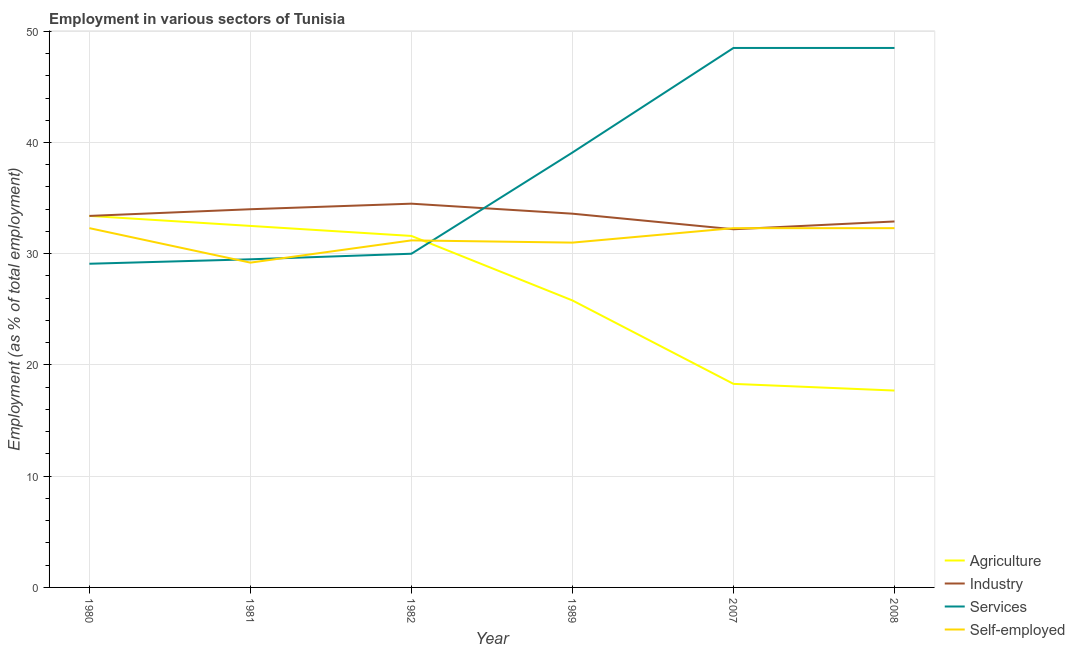How many different coloured lines are there?
Your response must be concise. 4. What is the percentage of workers in services in 2007?
Keep it short and to the point. 48.5. Across all years, what is the maximum percentage of workers in industry?
Give a very brief answer. 34.5. Across all years, what is the minimum percentage of workers in industry?
Provide a short and direct response. 32.2. In which year was the percentage of workers in industry maximum?
Keep it short and to the point. 1982. In which year was the percentage of workers in services minimum?
Ensure brevity in your answer.  1980. What is the total percentage of workers in services in the graph?
Offer a very short reply. 224.7. What is the difference between the percentage of workers in agriculture in 2007 and that in 2008?
Offer a terse response. 0.6. What is the difference between the percentage of workers in services in 1982 and the percentage of workers in industry in 2008?
Keep it short and to the point. -2.9. What is the average percentage of workers in services per year?
Ensure brevity in your answer.  37.45. In the year 1989, what is the difference between the percentage of workers in agriculture and percentage of workers in services?
Your answer should be very brief. -13.3. In how many years, is the percentage of workers in services greater than 2 %?
Offer a very short reply. 6. What is the ratio of the percentage of workers in services in 1989 to that in 2007?
Give a very brief answer. 0.81. What is the difference between the highest and the second highest percentage of workers in industry?
Keep it short and to the point. 0.5. What is the difference between the highest and the lowest percentage of self employed workers?
Make the answer very short. 3.1. In how many years, is the percentage of workers in services greater than the average percentage of workers in services taken over all years?
Your answer should be very brief. 3. Does the percentage of workers in agriculture monotonically increase over the years?
Offer a terse response. No. How many lines are there?
Offer a terse response. 4. Are the values on the major ticks of Y-axis written in scientific E-notation?
Offer a terse response. No. Does the graph contain any zero values?
Provide a succinct answer. No. Does the graph contain grids?
Provide a succinct answer. Yes. Where does the legend appear in the graph?
Keep it short and to the point. Bottom right. How many legend labels are there?
Offer a terse response. 4. How are the legend labels stacked?
Provide a short and direct response. Vertical. What is the title of the graph?
Give a very brief answer. Employment in various sectors of Tunisia. What is the label or title of the X-axis?
Your response must be concise. Year. What is the label or title of the Y-axis?
Make the answer very short. Employment (as % of total employment). What is the Employment (as % of total employment) of Agriculture in 1980?
Your answer should be compact. 33.4. What is the Employment (as % of total employment) of Industry in 1980?
Offer a very short reply. 33.4. What is the Employment (as % of total employment) of Services in 1980?
Your answer should be very brief. 29.1. What is the Employment (as % of total employment) in Self-employed in 1980?
Give a very brief answer. 32.3. What is the Employment (as % of total employment) in Agriculture in 1981?
Ensure brevity in your answer.  32.5. What is the Employment (as % of total employment) in Industry in 1981?
Offer a very short reply. 34. What is the Employment (as % of total employment) in Services in 1981?
Your response must be concise. 29.5. What is the Employment (as % of total employment) in Self-employed in 1981?
Keep it short and to the point. 29.2. What is the Employment (as % of total employment) in Agriculture in 1982?
Your answer should be compact. 31.6. What is the Employment (as % of total employment) in Industry in 1982?
Your answer should be very brief. 34.5. What is the Employment (as % of total employment) in Self-employed in 1982?
Keep it short and to the point. 31.2. What is the Employment (as % of total employment) of Agriculture in 1989?
Offer a very short reply. 25.8. What is the Employment (as % of total employment) in Industry in 1989?
Make the answer very short. 33.6. What is the Employment (as % of total employment) of Services in 1989?
Your answer should be compact. 39.1. What is the Employment (as % of total employment) in Self-employed in 1989?
Ensure brevity in your answer.  31. What is the Employment (as % of total employment) in Agriculture in 2007?
Offer a very short reply. 18.3. What is the Employment (as % of total employment) of Industry in 2007?
Make the answer very short. 32.2. What is the Employment (as % of total employment) of Services in 2007?
Provide a succinct answer. 48.5. What is the Employment (as % of total employment) of Self-employed in 2007?
Make the answer very short. 32.3. What is the Employment (as % of total employment) of Agriculture in 2008?
Provide a short and direct response. 17.7. What is the Employment (as % of total employment) of Industry in 2008?
Your response must be concise. 32.9. What is the Employment (as % of total employment) in Services in 2008?
Make the answer very short. 48.5. What is the Employment (as % of total employment) of Self-employed in 2008?
Provide a short and direct response. 32.3. Across all years, what is the maximum Employment (as % of total employment) of Agriculture?
Give a very brief answer. 33.4. Across all years, what is the maximum Employment (as % of total employment) of Industry?
Provide a succinct answer. 34.5. Across all years, what is the maximum Employment (as % of total employment) in Services?
Keep it short and to the point. 48.5. Across all years, what is the maximum Employment (as % of total employment) of Self-employed?
Keep it short and to the point. 32.3. Across all years, what is the minimum Employment (as % of total employment) of Agriculture?
Offer a very short reply. 17.7. Across all years, what is the minimum Employment (as % of total employment) in Industry?
Provide a succinct answer. 32.2. Across all years, what is the minimum Employment (as % of total employment) of Services?
Offer a very short reply. 29.1. Across all years, what is the minimum Employment (as % of total employment) in Self-employed?
Make the answer very short. 29.2. What is the total Employment (as % of total employment) in Agriculture in the graph?
Provide a short and direct response. 159.3. What is the total Employment (as % of total employment) of Industry in the graph?
Your answer should be very brief. 200.6. What is the total Employment (as % of total employment) in Services in the graph?
Your answer should be compact. 224.7. What is the total Employment (as % of total employment) in Self-employed in the graph?
Your answer should be compact. 188.3. What is the difference between the Employment (as % of total employment) of Agriculture in 1980 and that in 1981?
Offer a very short reply. 0.9. What is the difference between the Employment (as % of total employment) of Industry in 1980 and that in 1981?
Give a very brief answer. -0.6. What is the difference between the Employment (as % of total employment) in Industry in 1980 and that in 1982?
Make the answer very short. -1.1. What is the difference between the Employment (as % of total employment) in Self-employed in 1980 and that in 1982?
Give a very brief answer. 1.1. What is the difference between the Employment (as % of total employment) of Agriculture in 1980 and that in 1989?
Your response must be concise. 7.6. What is the difference between the Employment (as % of total employment) of Services in 1980 and that in 1989?
Provide a succinct answer. -10. What is the difference between the Employment (as % of total employment) in Self-employed in 1980 and that in 1989?
Offer a very short reply. 1.3. What is the difference between the Employment (as % of total employment) in Services in 1980 and that in 2007?
Offer a very short reply. -19.4. What is the difference between the Employment (as % of total employment) in Industry in 1980 and that in 2008?
Give a very brief answer. 0.5. What is the difference between the Employment (as % of total employment) in Services in 1980 and that in 2008?
Offer a terse response. -19.4. What is the difference between the Employment (as % of total employment) in Self-employed in 1980 and that in 2008?
Make the answer very short. 0. What is the difference between the Employment (as % of total employment) in Agriculture in 1981 and that in 1989?
Provide a succinct answer. 6.7. What is the difference between the Employment (as % of total employment) of Self-employed in 1981 and that in 1989?
Your answer should be very brief. -1.8. What is the difference between the Employment (as % of total employment) in Agriculture in 1981 and that in 2007?
Your response must be concise. 14.2. What is the difference between the Employment (as % of total employment) of Services in 1981 and that in 2007?
Your answer should be very brief. -19. What is the difference between the Employment (as % of total employment) of Self-employed in 1981 and that in 2007?
Make the answer very short. -3.1. What is the difference between the Employment (as % of total employment) of Services in 1981 and that in 2008?
Keep it short and to the point. -19. What is the difference between the Employment (as % of total employment) in Services in 1982 and that in 1989?
Give a very brief answer. -9.1. What is the difference between the Employment (as % of total employment) in Industry in 1982 and that in 2007?
Give a very brief answer. 2.3. What is the difference between the Employment (as % of total employment) of Services in 1982 and that in 2007?
Give a very brief answer. -18.5. What is the difference between the Employment (as % of total employment) in Self-employed in 1982 and that in 2007?
Ensure brevity in your answer.  -1.1. What is the difference between the Employment (as % of total employment) of Agriculture in 1982 and that in 2008?
Offer a terse response. 13.9. What is the difference between the Employment (as % of total employment) in Services in 1982 and that in 2008?
Offer a very short reply. -18.5. What is the difference between the Employment (as % of total employment) of Self-employed in 1982 and that in 2008?
Offer a terse response. -1.1. What is the difference between the Employment (as % of total employment) of Agriculture in 1989 and that in 2007?
Provide a succinct answer. 7.5. What is the difference between the Employment (as % of total employment) in Agriculture in 1989 and that in 2008?
Ensure brevity in your answer.  8.1. What is the difference between the Employment (as % of total employment) of Services in 1989 and that in 2008?
Ensure brevity in your answer.  -9.4. What is the difference between the Employment (as % of total employment) in Self-employed in 1989 and that in 2008?
Keep it short and to the point. -1.3. What is the difference between the Employment (as % of total employment) of Industry in 2007 and that in 2008?
Keep it short and to the point. -0.7. What is the difference between the Employment (as % of total employment) in Services in 2007 and that in 2008?
Give a very brief answer. 0. What is the difference between the Employment (as % of total employment) of Agriculture in 1980 and the Employment (as % of total employment) of Self-employed in 1981?
Your response must be concise. 4.2. What is the difference between the Employment (as % of total employment) of Agriculture in 1980 and the Employment (as % of total employment) of Self-employed in 1982?
Keep it short and to the point. 2.2. What is the difference between the Employment (as % of total employment) of Industry in 1980 and the Employment (as % of total employment) of Self-employed in 1982?
Your answer should be very brief. 2.2. What is the difference between the Employment (as % of total employment) of Services in 1980 and the Employment (as % of total employment) of Self-employed in 1982?
Ensure brevity in your answer.  -2.1. What is the difference between the Employment (as % of total employment) in Agriculture in 1980 and the Employment (as % of total employment) in Industry in 1989?
Offer a very short reply. -0.2. What is the difference between the Employment (as % of total employment) in Agriculture in 1980 and the Employment (as % of total employment) in Services in 1989?
Make the answer very short. -5.7. What is the difference between the Employment (as % of total employment) of Industry in 1980 and the Employment (as % of total employment) of Self-employed in 1989?
Give a very brief answer. 2.4. What is the difference between the Employment (as % of total employment) of Agriculture in 1980 and the Employment (as % of total employment) of Services in 2007?
Ensure brevity in your answer.  -15.1. What is the difference between the Employment (as % of total employment) of Industry in 1980 and the Employment (as % of total employment) of Services in 2007?
Keep it short and to the point. -15.1. What is the difference between the Employment (as % of total employment) of Agriculture in 1980 and the Employment (as % of total employment) of Industry in 2008?
Offer a terse response. 0.5. What is the difference between the Employment (as % of total employment) in Agriculture in 1980 and the Employment (as % of total employment) in Services in 2008?
Keep it short and to the point. -15.1. What is the difference between the Employment (as % of total employment) in Industry in 1980 and the Employment (as % of total employment) in Services in 2008?
Provide a succinct answer. -15.1. What is the difference between the Employment (as % of total employment) in Services in 1980 and the Employment (as % of total employment) in Self-employed in 2008?
Ensure brevity in your answer.  -3.2. What is the difference between the Employment (as % of total employment) of Agriculture in 1981 and the Employment (as % of total employment) of Services in 1982?
Offer a very short reply. 2.5. What is the difference between the Employment (as % of total employment) in Industry in 1981 and the Employment (as % of total employment) in Self-employed in 1982?
Provide a succinct answer. 2.8. What is the difference between the Employment (as % of total employment) in Agriculture in 1981 and the Employment (as % of total employment) in Industry in 1989?
Provide a short and direct response. -1.1. What is the difference between the Employment (as % of total employment) in Industry in 1981 and the Employment (as % of total employment) in Services in 1989?
Your answer should be very brief. -5.1. What is the difference between the Employment (as % of total employment) in Industry in 1981 and the Employment (as % of total employment) in Self-employed in 1989?
Ensure brevity in your answer.  3. What is the difference between the Employment (as % of total employment) in Services in 1981 and the Employment (as % of total employment) in Self-employed in 1989?
Provide a short and direct response. -1.5. What is the difference between the Employment (as % of total employment) in Agriculture in 1981 and the Employment (as % of total employment) in Self-employed in 2007?
Provide a succinct answer. 0.2. What is the difference between the Employment (as % of total employment) in Industry in 1981 and the Employment (as % of total employment) in Self-employed in 2007?
Your answer should be compact. 1.7. What is the difference between the Employment (as % of total employment) of Agriculture in 1981 and the Employment (as % of total employment) of Industry in 2008?
Offer a terse response. -0.4. What is the difference between the Employment (as % of total employment) in Agriculture in 1981 and the Employment (as % of total employment) in Services in 2008?
Provide a succinct answer. -16. What is the difference between the Employment (as % of total employment) of Agriculture in 1981 and the Employment (as % of total employment) of Self-employed in 2008?
Offer a terse response. 0.2. What is the difference between the Employment (as % of total employment) in Agriculture in 1982 and the Employment (as % of total employment) in Industry in 1989?
Your response must be concise. -2. What is the difference between the Employment (as % of total employment) of Industry in 1982 and the Employment (as % of total employment) of Services in 1989?
Offer a terse response. -4.6. What is the difference between the Employment (as % of total employment) of Agriculture in 1982 and the Employment (as % of total employment) of Services in 2007?
Give a very brief answer. -16.9. What is the difference between the Employment (as % of total employment) in Agriculture in 1982 and the Employment (as % of total employment) in Self-employed in 2007?
Provide a succinct answer. -0.7. What is the difference between the Employment (as % of total employment) in Agriculture in 1982 and the Employment (as % of total employment) in Industry in 2008?
Your answer should be compact. -1.3. What is the difference between the Employment (as % of total employment) of Agriculture in 1982 and the Employment (as % of total employment) of Services in 2008?
Make the answer very short. -16.9. What is the difference between the Employment (as % of total employment) in Agriculture in 1982 and the Employment (as % of total employment) in Self-employed in 2008?
Your answer should be very brief. -0.7. What is the difference between the Employment (as % of total employment) of Industry in 1982 and the Employment (as % of total employment) of Services in 2008?
Your answer should be very brief. -14. What is the difference between the Employment (as % of total employment) in Services in 1982 and the Employment (as % of total employment) in Self-employed in 2008?
Your response must be concise. -2.3. What is the difference between the Employment (as % of total employment) in Agriculture in 1989 and the Employment (as % of total employment) in Services in 2007?
Ensure brevity in your answer.  -22.7. What is the difference between the Employment (as % of total employment) in Industry in 1989 and the Employment (as % of total employment) in Services in 2007?
Make the answer very short. -14.9. What is the difference between the Employment (as % of total employment) in Services in 1989 and the Employment (as % of total employment) in Self-employed in 2007?
Offer a very short reply. 6.8. What is the difference between the Employment (as % of total employment) of Agriculture in 1989 and the Employment (as % of total employment) of Industry in 2008?
Give a very brief answer. -7.1. What is the difference between the Employment (as % of total employment) in Agriculture in 1989 and the Employment (as % of total employment) in Services in 2008?
Keep it short and to the point. -22.7. What is the difference between the Employment (as % of total employment) of Agriculture in 1989 and the Employment (as % of total employment) of Self-employed in 2008?
Give a very brief answer. -6.5. What is the difference between the Employment (as % of total employment) of Industry in 1989 and the Employment (as % of total employment) of Services in 2008?
Provide a succinct answer. -14.9. What is the difference between the Employment (as % of total employment) of Agriculture in 2007 and the Employment (as % of total employment) of Industry in 2008?
Make the answer very short. -14.6. What is the difference between the Employment (as % of total employment) in Agriculture in 2007 and the Employment (as % of total employment) in Services in 2008?
Offer a terse response. -30.2. What is the difference between the Employment (as % of total employment) in Agriculture in 2007 and the Employment (as % of total employment) in Self-employed in 2008?
Your response must be concise. -14. What is the difference between the Employment (as % of total employment) in Industry in 2007 and the Employment (as % of total employment) in Services in 2008?
Make the answer very short. -16.3. What is the difference between the Employment (as % of total employment) of Industry in 2007 and the Employment (as % of total employment) of Self-employed in 2008?
Ensure brevity in your answer.  -0.1. What is the difference between the Employment (as % of total employment) in Services in 2007 and the Employment (as % of total employment) in Self-employed in 2008?
Provide a succinct answer. 16.2. What is the average Employment (as % of total employment) in Agriculture per year?
Your response must be concise. 26.55. What is the average Employment (as % of total employment) of Industry per year?
Provide a short and direct response. 33.43. What is the average Employment (as % of total employment) in Services per year?
Provide a succinct answer. 37.45. What is the average Employment (as % of total employment) in Self-employed per year?
Your answer should be compact. 31.38. In the year 1980, what is the difference between the Employment (as % of total employment) of Industry and Employment (as % of total employment) of Services?
Give a very brief answer. 4.3. In the year 1980, what is the difference between the Employment (as % of total employment) in Industry and Employment (as % of total employment) in Self-employed?
Your answer should be compact. 1.1. In the year 1981, what is the difference between the Employment (as % of total employment) of Agriculture and Employment (as % of total employment) of Services?
Your answer should be very brief. 3. In the year 1981, what is the difference between the Employment (as % of total employment) in Industry and Employment (as % of total employment) in Services?
Your answer should be very brief. 4.5. In the year 1981, what is the difference between the Employment (as % of total employment) in Industry and Employment (as % of total employment) in Self-employed?
Offer a terse response. 4.8. In the year 1981, what is the difference between the Employment (as % of total employment) of Services and Employment (as % of total employment) of Self-employed?
Make the answer very short. 0.3. In the year 1982, what is the difference between the Employment (as % of total employment) in Agriculture and Employment (as % of total employment) in Services?
Your answer should be very brief. 1.6. In the year 1982, what is the difference between the Employment (as % of total employment) in Industry and Employment (as % of total employment) in Services?
Your answer should be compact. 4.5. In the year 1982, what is the difference between the Employment (as % of total employment) in Industry and Employment (as % of total employment) in Self-employed?
Your answer should be compact. 3.3. In the year 1982, what is the difference between the Employment (as % of total employment) in Services and Employment (as % of total employment) in Self-employed?
Keep it short and to the point. -1.2. In the year 1989, what is the difference between the Employment (as % of total employment) in Agriculture and Employment (as % of total employment) in Industry?
Offer a very short reply. -7.8. In the year 1989, what is the difference between the Employment (as % of total employment) of Industry and Employment (as % of total employment) of Self-employed?
Your answer should be very brief. 2.6. In the year 2007, what is the difference between the Employment (as % of total employment) in Agriculture and Employment (as % of total employment) in Industry?
Your response must be concise. -13.9. In the year 2007, what is the difference between the Employment (as % of total employment) of Agriculture and Employment (as % of total employment) of Services?
Provide a succinct answer. -30.2. In the year 2007, what is the difference between the Employment (as % of total employment) in Industry and Employment (as % of total employment) in Services?
Provide a succinct answer. -16.3. In the year 2008, what is the difference between the Employment (as % of total employment) of Agriculture and Employment (as % of total employment) of Industry?
Your answer should be very brief. -15.2. In the year 2008, what is the difference between the Employment (as % of total employment) of Agriculture and Employment (as % of total employment) of Services?
Make the answer very short. -30.8. In the year 2008, what is the difference between the Employment (as % of total employment) in Agriculture and Employment (as % of total employment) in Self-employed?
Your response must be concise. -14.6. In the year 2008, what is the difference between the Employment (as % of total employment) of Industry and Employment (as % of total employment) of Services?
Keep it short and to the point. -15.6. In the year 2008, what is the difference between the Employment (as % of total employment) of Services and Employment (as % of total employment) of Self-employed?
Your answer should be compact. 16.2. What is the ratio of the Employment (as % of total employment) of Agriculture in 1980 to that in 1981?
Ensure brevity in your answer.  1.03. What is the ratio of the Employment (as % of total employment) of Industry in 1980 to that in 1981?
Provide a succinct answer. 0.98. What is the ratio of the Employment (as % of total employment) in Services in 1980 to that in 1981?
Ensure brevity in your answer.  0.99. What is the ratio of the Employment (as % of total employment) in Self-employed in 1980 to that in 1981?
Offer a terse response. 1.11. What is the ratio of the Employment (as % of total employment) in Agriculture in 1980 to that in 1982?
Your answer should be very brief. 1.06. What is the ratio of the Employment (as % of total employment) of Industry in 1980 to that in 1982?
Keep it short and to the point. 0.97. What is the ratio of the Employment (as % of total employment) of Self-employed in 1980 to that in 1982?
Offer a terse response. 1.04. What is the ratio of the Employment (as % of total employment) of Agriculture in 1980 to that in 1989?
Ensure brevity in your answer.  1.29. What is the ratio of the Employment (as % of total employment) in Services in 1980 to that in 1989?
Offer a very short reply. 0.74. What is the ratio of the Employment (as % of total employment) in Self-employed in 1980 to that in 1989?
Provide a short and direct response. 1.04. What is the ratio of the Employment (as % of total employment) of Agriculture in 1980 to that in 2007?
Offer a terse response. 1.83. What is the ratio of the Employment (as % of total employment) in Industry in 1980 to that in 2007?
Provide a succinct answer. 1.04. What is the ratio of the Employment (as % of total employment) of Self-employed in 1980 to that in 2007?
Provide a short and direct response. 1. What is the ratio of the Employment (as % of total employment) of Agriculture in 1980 to that in 2008?
Make the answer very short. 1.89. What is the ratio of the Employment (as % of total employment) of Industry in 1980 to that in 2008?
Your answer should be very brief. 1.02. What is the ratio of the Employment (as % of total employment) in Self-employed in 1980 to that in 2008?
Provide a short and direct response. 1. What is the ratio of the Employment (as % of total employment) of Agriculture in 1981 to that in 1982?
Ensure brevity in your answer.  1.03. What is the ratio of the Employment (as % of total employment) in Industry in 1981 to that in 1982?
Your response must be concise. 0.99. What is the ratio of the Employment (as % of total employment) in Services in 1981 to that in 1982?
Your answer should be very brief. 0.98. What is the ratio of the Employment (as % of total employment) of Self-employed in 1981 to that in 1982?
Offer a very short reply. 0.94. What is the ratio of the Employment (as % of total employment) of Agriculture in 1981 to that in 1989?
Give a very brief answer. 1.26. What is the ratio of the Employment (as % of total employment) in Industry in 1981 to that in 1989?
Make the answer very short. 1.01. What is the ratio of the Employment (as % of total employment) in Services in 1981 to that in 1989?
Keep it short and to the point. 0.75. What is the ratio of the Employment (as % of total employment) in Self-employed in 1981 to that in 1989?
Keep it short and to the point. 0.94. What is the ratio of the Employment (as % of total employment) of Agriculture in 1981 to that in 2007?
Ensure brevity in your answer.  1.78. What is the ratio of the Employment (as % of total employment) in Industry in 1981 to that in 2007?
Your answer should be very brief. 1.06. What is the ratio of the Employment (as % of total employment) of Services in 1981 to that in 2007?
Keep it short and to the point. 0.61. What is the ratio of the Employment (as % of total employment) in Self-employed in 1981 to that in 2007?
Your answer should be compact. 0.9. What is the ratio of the Employment (as % of total employment) of Agriculture in 1981 to that in 2008?
Give a very brief answer. 1.84. What is the ratio of the Employment (as % of total employment) of Industry in 1981 to that in 2008?
Keep it short and to the point. 1.03. What is the ratio of the Employment (as % of total employment) in Services in 1981 to that in 2008?
Provide a short and direct response. 0.61. What is the ratio of the Employment (as % of total employment) in Self-employed in 1981 to that in 2008?
Provide a short and direct response. 0.9. What is the ratio of the Employment (as % of total employment) of Agriculture in 1982 to that in 1989?
Offer a very short reply. 1.22. What is the ratio of the Employment (as % of total employment) in Industry in 1982 to that in 1989?
Your answer should be very brief. 1.03. What is the ratio of the Employment (as % of total employment) of Services in 1982 to that in 1989?
Your answer should be compact. 0.77. What is the ratio of the Employment (as % of total employment) in Self-employed in 1982 to that in 1989?
Provide a short and direct response. 1.01. What is the ratio of the Employment (as % of total employment) of Agriculture in 1982 to that in 2007?
Your answer should be compact. 1.73. What is the ratio of the Employment (as % of total employment) in Industry in 1982 to that in 2007?
Keep it short and to the point. 1.07. What is the ratio of the Employment (as % of total employment) of Services in 1982 to that in 2007?
Give a very brief answer. 0.62. What is the ratio of the Employment (as % of total employment) in Self-employed in 1982 to that in 2007?
Provide a succinct answer. 0.97. What is the ratio of the Employment (as % of total employment) of Agriculture in 1982 to that in 2008?
Ensure brevity in your answer.  1.79. What is the ratio of the Employment (as % of total employment) of Industry in 1982 to that in 2008?
Keep it short and to the point. 1.05. What is the ratio of the Employment (as % of total employment) of Services in 1982 to that in 2008?
Keep it short and to the point. 0.62. What is the ratio of the Employment (as % of total employment) of Self-employed in 1982 to that in 2008?
Offer a terse response. 0.97. What is the ratio of the Employment (as % of total employment) of Agriculture in 1989 to that in 2007?
Provide a succinct answer. 1.41. What is the ratio of the Employment (as % of total employment) in Industry in 1989 to that in 2007?
Provide a succinct answer. 1.04. What is the ratio of the Employment (as % of total employment) of Services in 1989 to that in 2007?
Offer a very short reply. 0.81. What is the ratio of the Employment (as % of total employment) of Self-employed in 1989 to that in 2007?
Offer a very short reply. 0.96. What is the ratio of the Employment (as % of total employment) in Agriculture in 1989 to that in 2008?
Your answer should be compact. 1.46. What is the ratio of the Employment (as % of total employment) of Industry in 1989 to that in 2008?
Your answer should be very brief. 1.02. What is the ratio of the Employment (as % of total employment) in Services in 1989 to that in 2008?
Your response must be concise. 0.81. What is the ratio of the Employment (as % of total employment) of Self-employed in 1989 to that in 2008?
Provide a short and direct response. 0.96. What is the ratio of the Employment (as % of total employment) in Agriculture in 2007 to that in 2008?
Your answer should be compact. 1.03. What is the ratio of the Employment (as % of total employment) in Industry in 2007 to that in 2008?
Give a very brief answer. 0.98. What is the ratio of the Employment (as % of total employment) in Services in 2007 to that in 2008?
Provide a succinct answer. 1. What is the ratio of the Employment (as % of total employment) in Self-employed in 2007 to that in 2008?
Provide a succinct answer. 1. What is the difference between the highest and the second highest Employment (as % of total employment) of Agriculture?
Keep it short and to the point. 0.9. What is the difference between the highest and the second highest Employment (as % of total employment) in Industry?
Provide a short and direct response. 0.5. What is the difference between the highest and the second highest Employment (as % of total employment) in Services?
Offer a very short reply. 0. What is the difference between the highest and the second highest Employment (as % of total employment) in Self-employed?
Provide a succinct answer. 0. What is the difference between the highest and the lowest Employment (as % of total employment) of Industry?
Ensure brevity in your answer.  2.3. What is the difference between the highest and the lowest Employment (as % of total employment) in Self-employed?
Give a very brief answer. 3.1. 